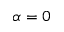Convert formula to latex. <formula><loc_0><loc_0><loc_500><loc_500>\alpha = 0</formula> 